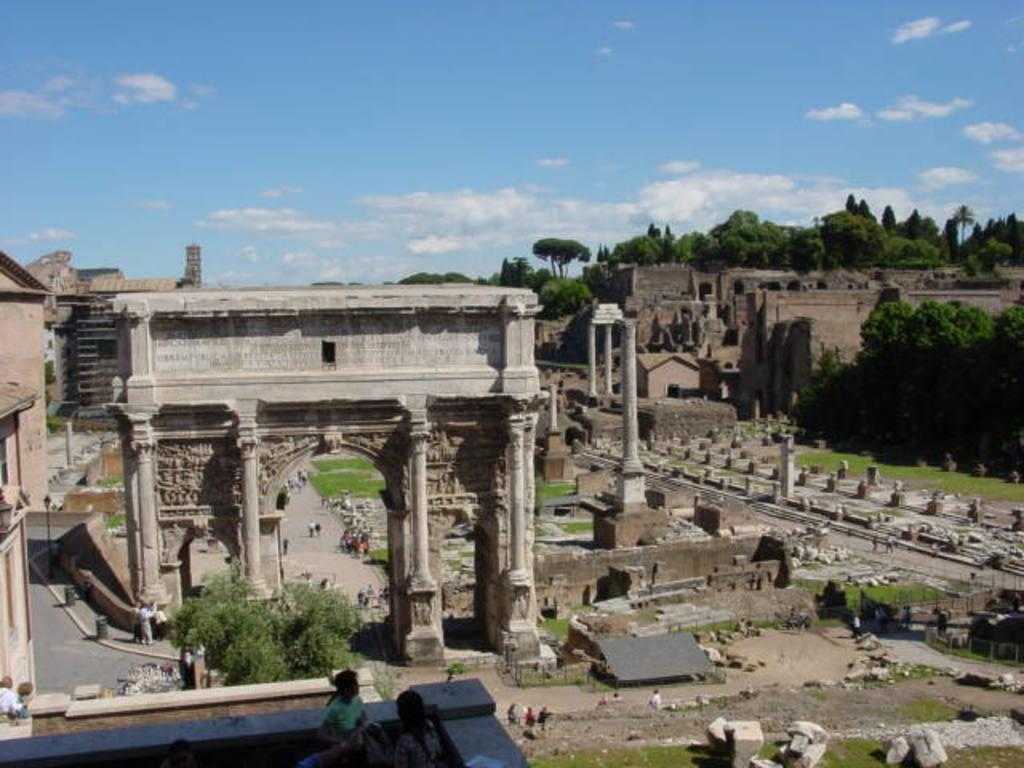What type of vegetation can be seen in the image? There are trees in the image. What type of structure is present in the image? There is a fort in the image. What architectural elements can be seen in the image? There are pillars in the image. What type of ground surface is visible in the image? There are stones and grass in the image. What type of environment is depicted in the image? There are trees, grass, and buildings in the image. Are there any people present in the image? Yes, there are people in the image. What type of infrastructure is visible in the image? There is a road in the image. What can be seen in the sky in the image? There is sky visible in the image, with clouds present. What type of stick is being used by the people in the image? There is no stick visible in the image. What type of rifle can be seen in the hands of the people in the image? There are no rifles present in the image. 